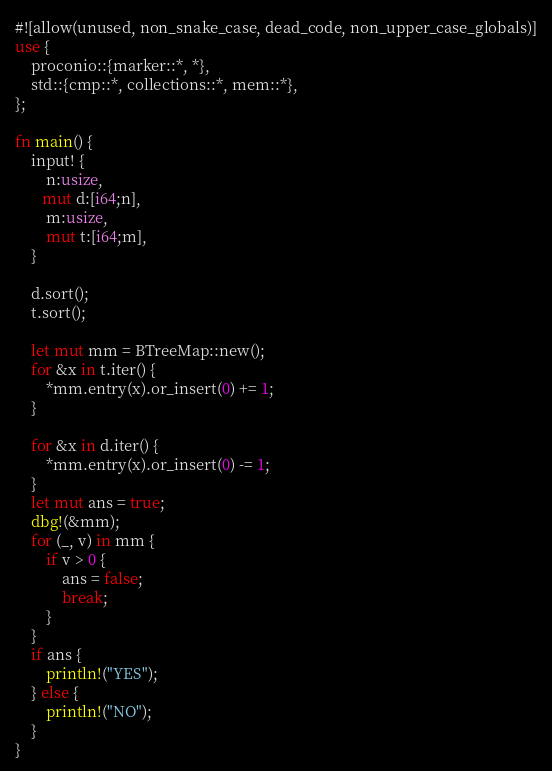Convert code to text. <code><loc_0><loc_0><loc_500><loc_500><_Rust_>#![allow(unused, non_snake_case, dead_code, non_upper_case_globals)]
use {
    proconio::{marker::*, *},
    std::{cmp::*, collections::*, mem::*},
};

fn main() {
    input! {
        n:usize,
       mut d:[i64;n],
        m:usize,
        mut t:[i64;m],
    }

    d.sort();
    t.sort();

    let mut mm = BTreeMap::new();
    for &x in t.iter() {
        *mm.entry(x).or_insert(0) += 1;
    }

    for &x in d.iter() {
        *mm.entry(x).or_insert(0) -= 1;
    }
    let mut ans = true;
    dbg!(&mm);
    for (_, v) in mm {
        if v > 0 {
            ans = false;
            break;
        }
    }
    if ans {
        println!("YES");
    } else {
        println!("NO");
    }
}
</code> 